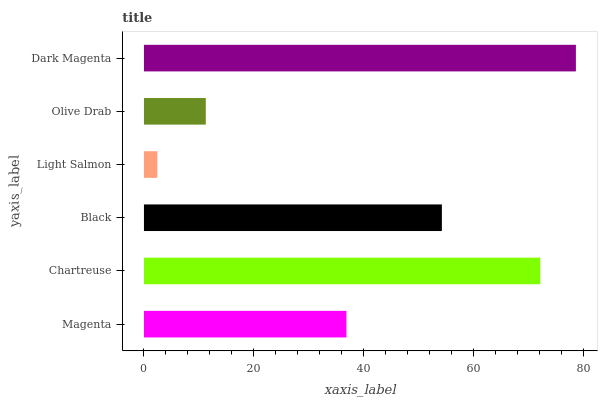Is Light Salmon the minimum?
Answer yes or no. Yes. Is Dark Magenta the maximum?
Answer yes or no. Yes. Is Chartreuse the minimum?
Answer yes or no. No. Is Chartreuse the maximum?
Answer yes or no. No. Is Chartreuse greater than Magenta?
Answer yes or no. Yes. Is Magenta less than Chartreuse?
Answer yes or no. Yes. Is Magenta greater than Chartreuse?
Answer yes or no. No. Is Chartreuse less than Magenta?
Answer yes or no. No. Is Black the high median?
Answer yes or no. Yes. Is Magenta the low median?
Answer yes or no. Yes. Is Magenta the high median?
Answer yes or no. No. Is Black the low median?
Answer yes or no. No. 